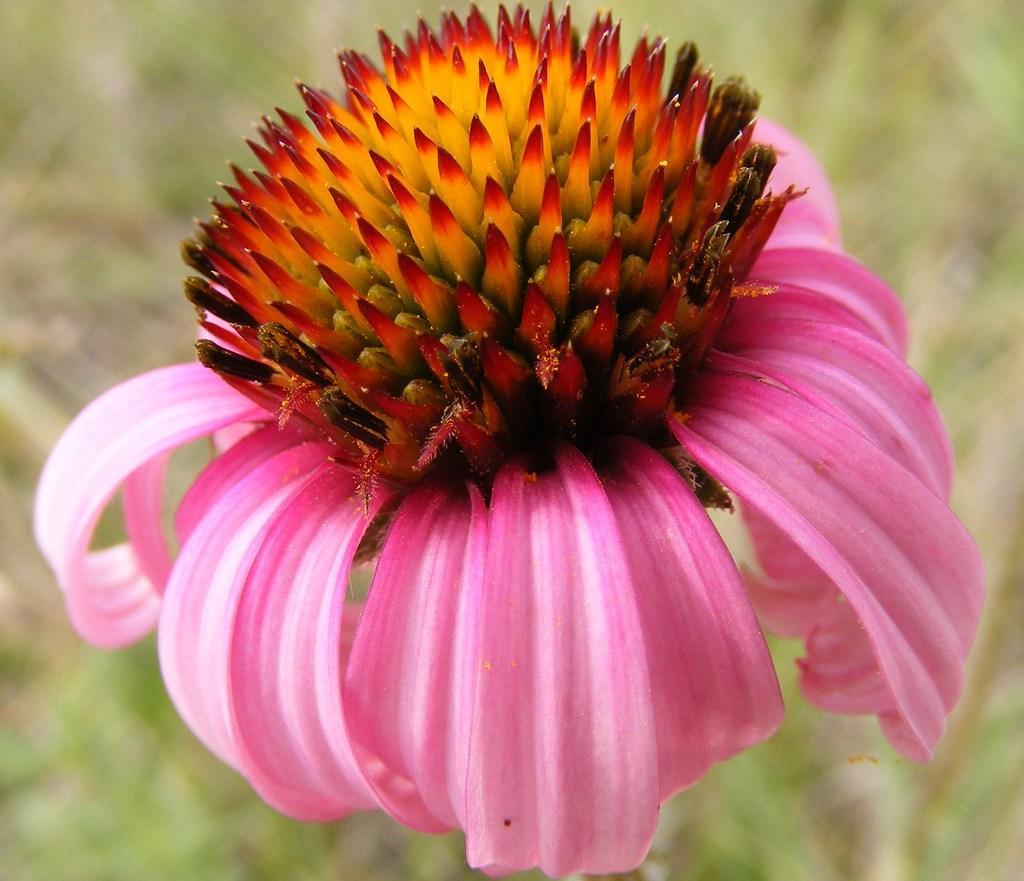Please provide a concise description of this image. In this picture there is a flower on the plant and the flower is in pink, red and in yellow color. At the back the image is blurry. 